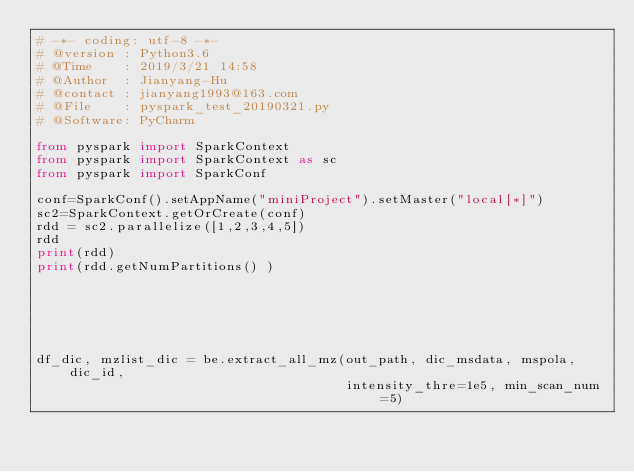Convert code to text. <code><loc_0><loc_0><loc_500><loc_500><_Python_># -*- coding: utf-8 -*-
# @version : Python3.6
# @Time    : 2019/3/21 14:58
# @Author  : Jianyang-Hu
# @contact : jianyang1993@163.com
# @File    : pyspark_test_20190321.py
# @Software: PyCharm

from pyspark import SparkContext
from pyspark import SparkContext as sc
from pyspark import SparkConf

conf=SparkConf().setAppName("miniProject").setMaster("local[*]")
sc2=SparkContext.getOrCreate(conf)
rdd = sc2.parallelize([1,2,3,4,5])
rdd
print(rdd)
print(rdd.getNumPartitions() )






df_dic, mzlist_dic = be.extract_all_mz(out_path, dic_msdata, mspola, dic_id,
                                       intensity_thre=1e5, min_scan_num=5)</code> 